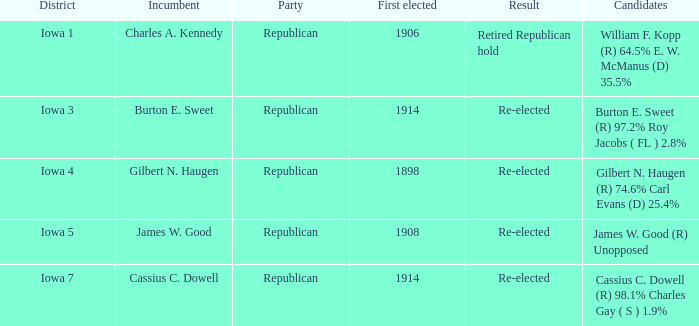What political affiliation for burton e. sweet? Republican. 